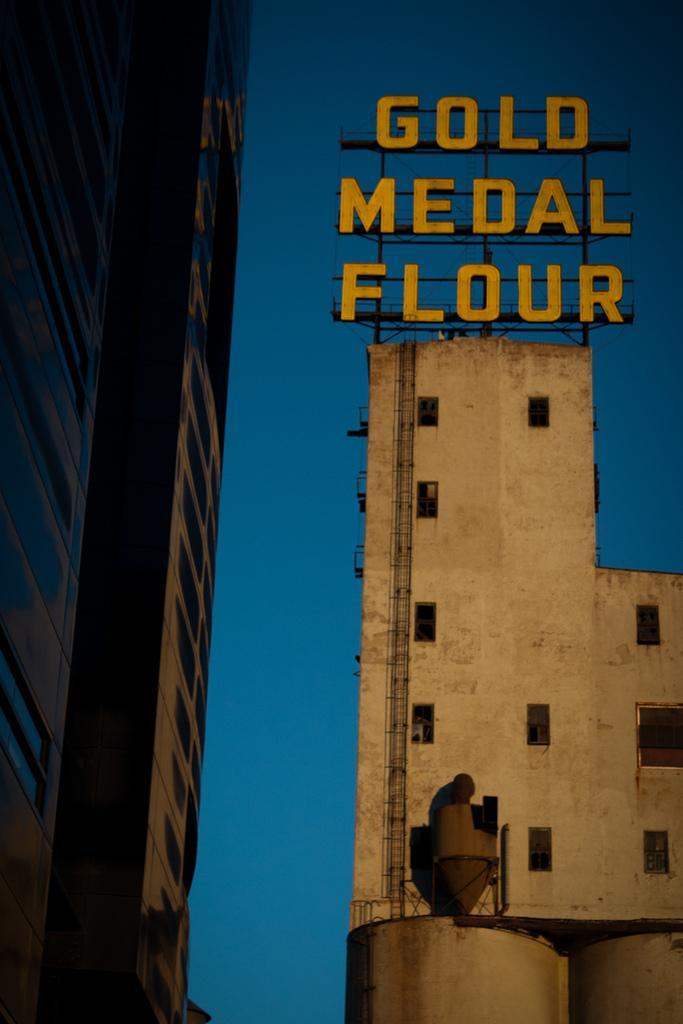How would you summarize this image in a sentence or two? In this image, there are buildings and it looks like a chimney. There is a name board on top of a building. In the background there is the sky. 